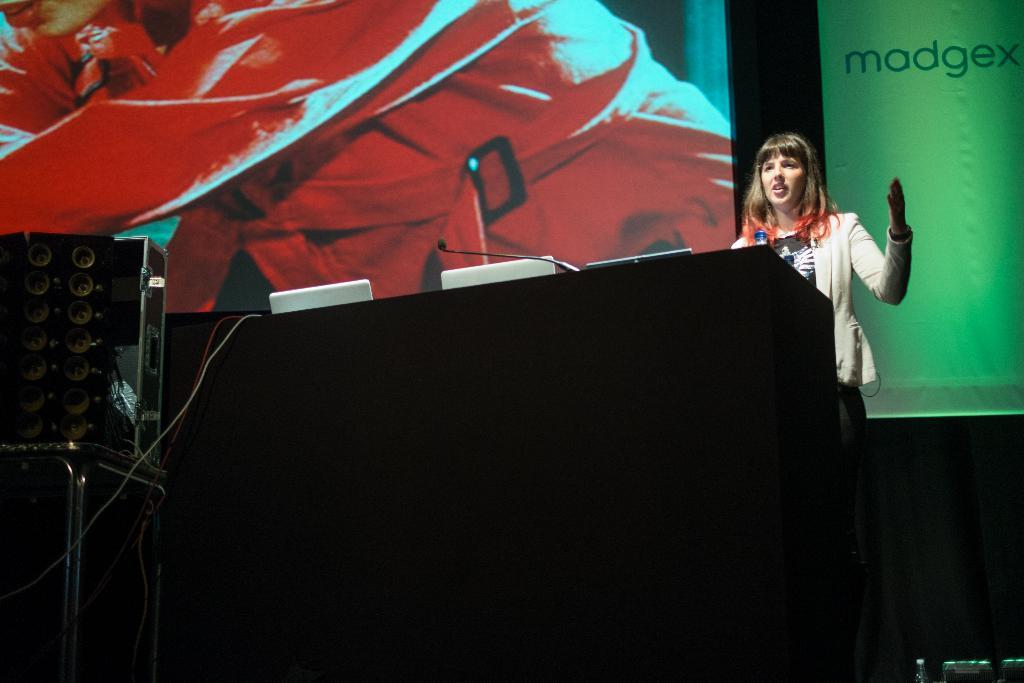Who is present in the image? There is a woman in the image. What object can be seen near the woman? There is a bottle in the image. What electronic devices are visible in the image? There are laptops in the image. What device is used for amplifying sound? There is a microphone (mic) in the image. What are the cables used for in the image? The cables are used to connect devices in the image. What other objects can be seen in the image? There are devices and a poster in the image. What is visible in the background of the image? There is a screen and a dark background in the image. What type of cover is on the apple in the image? There is no apple or cover present in the image. 